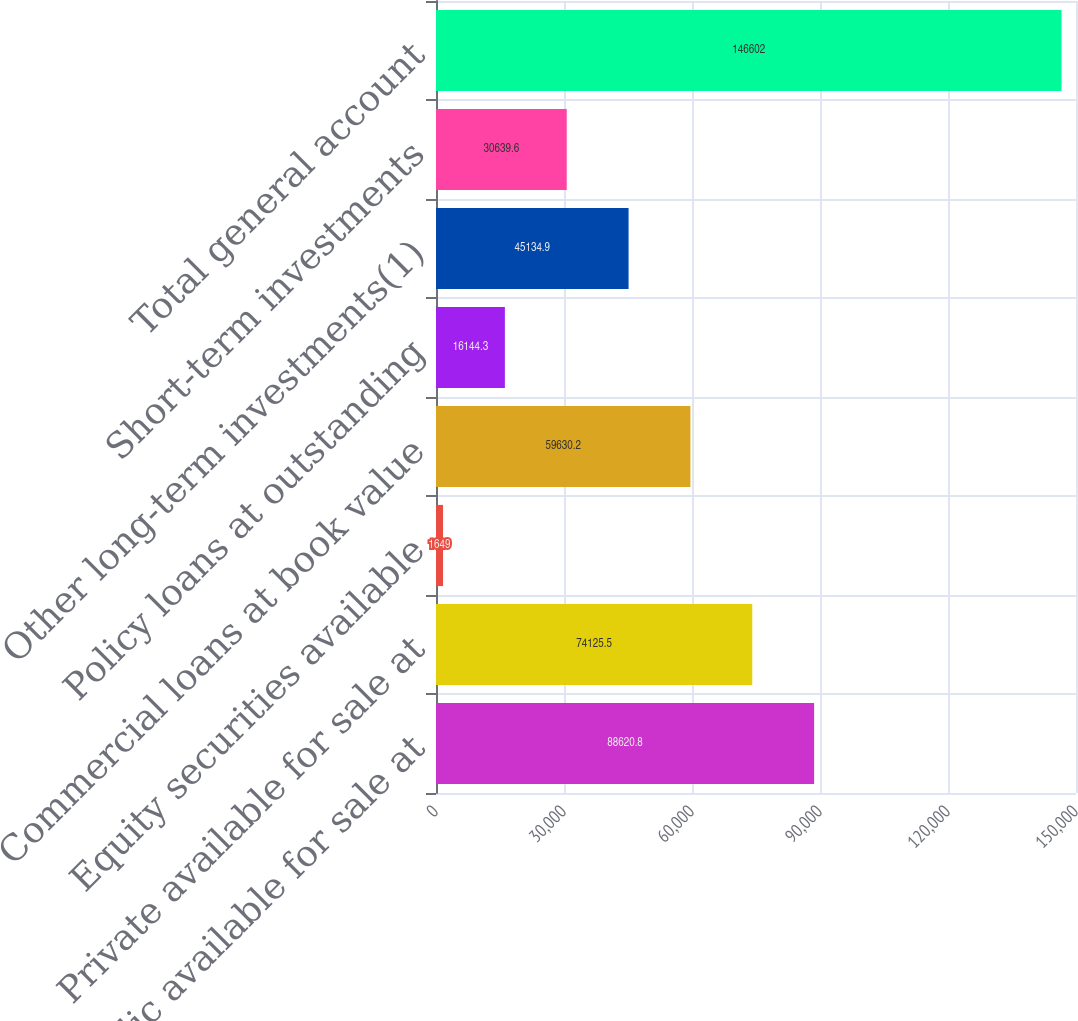<chart> <loc_0><loc_0><loc_500><loc_500><bar_chart><fcel>Public available for sale at<fcel>Private available for sale at<fcel>Equity securities available<fcel>Commercial loans at book value<fcel>Policy loans at outstanding<fcel>Other long-term investments(1)<fcel>Short-term investments<fcel>Total general account<nl><fcel>88620.8<fcel>74125.5<fcel>1649<fcel>59630.2<fcel>16144.3<fcel>45134.9<fcel>30639.6<fcel>146602<nl></chart> 